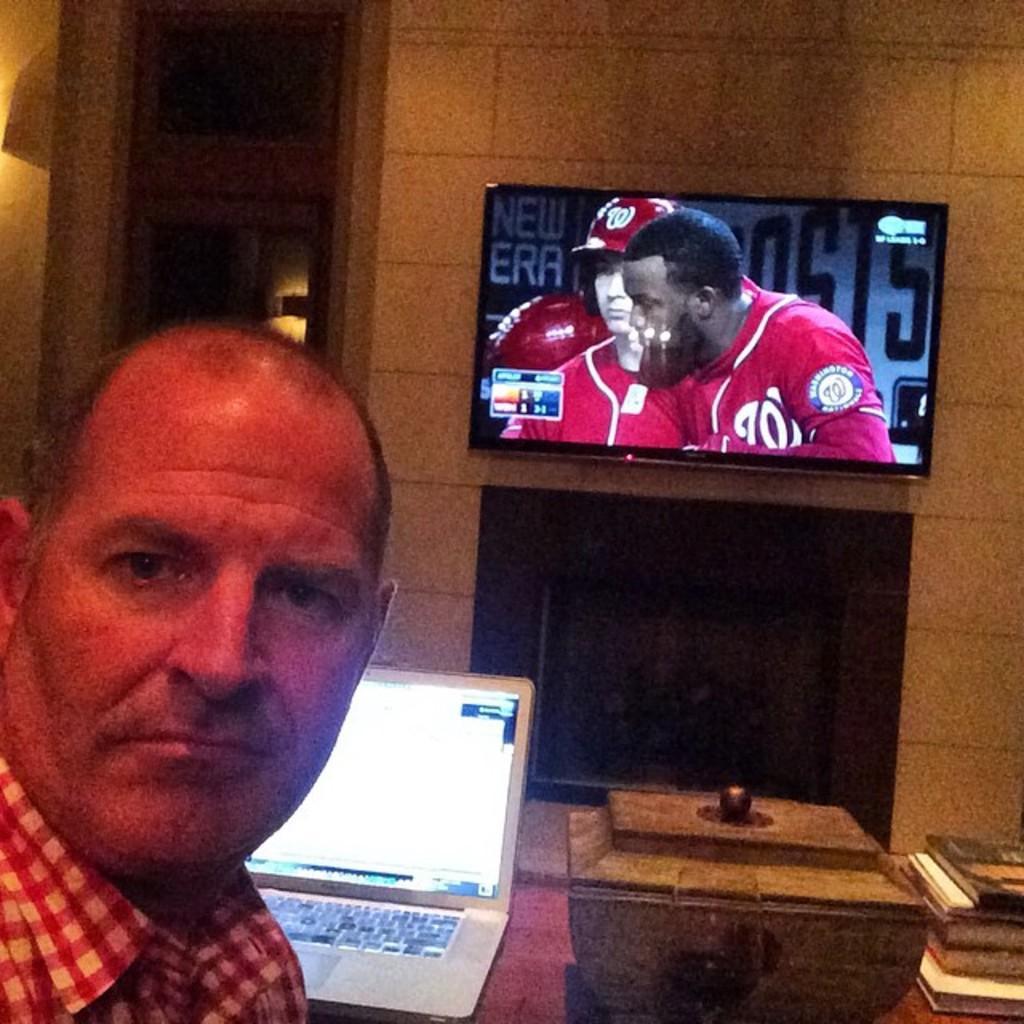Describe this image in one or two sentences. This is the picture of a of a person who is sitting in front of the desk on which there is a laptop and in front of him there is a screen to the wall and some books and some things to the other side. 